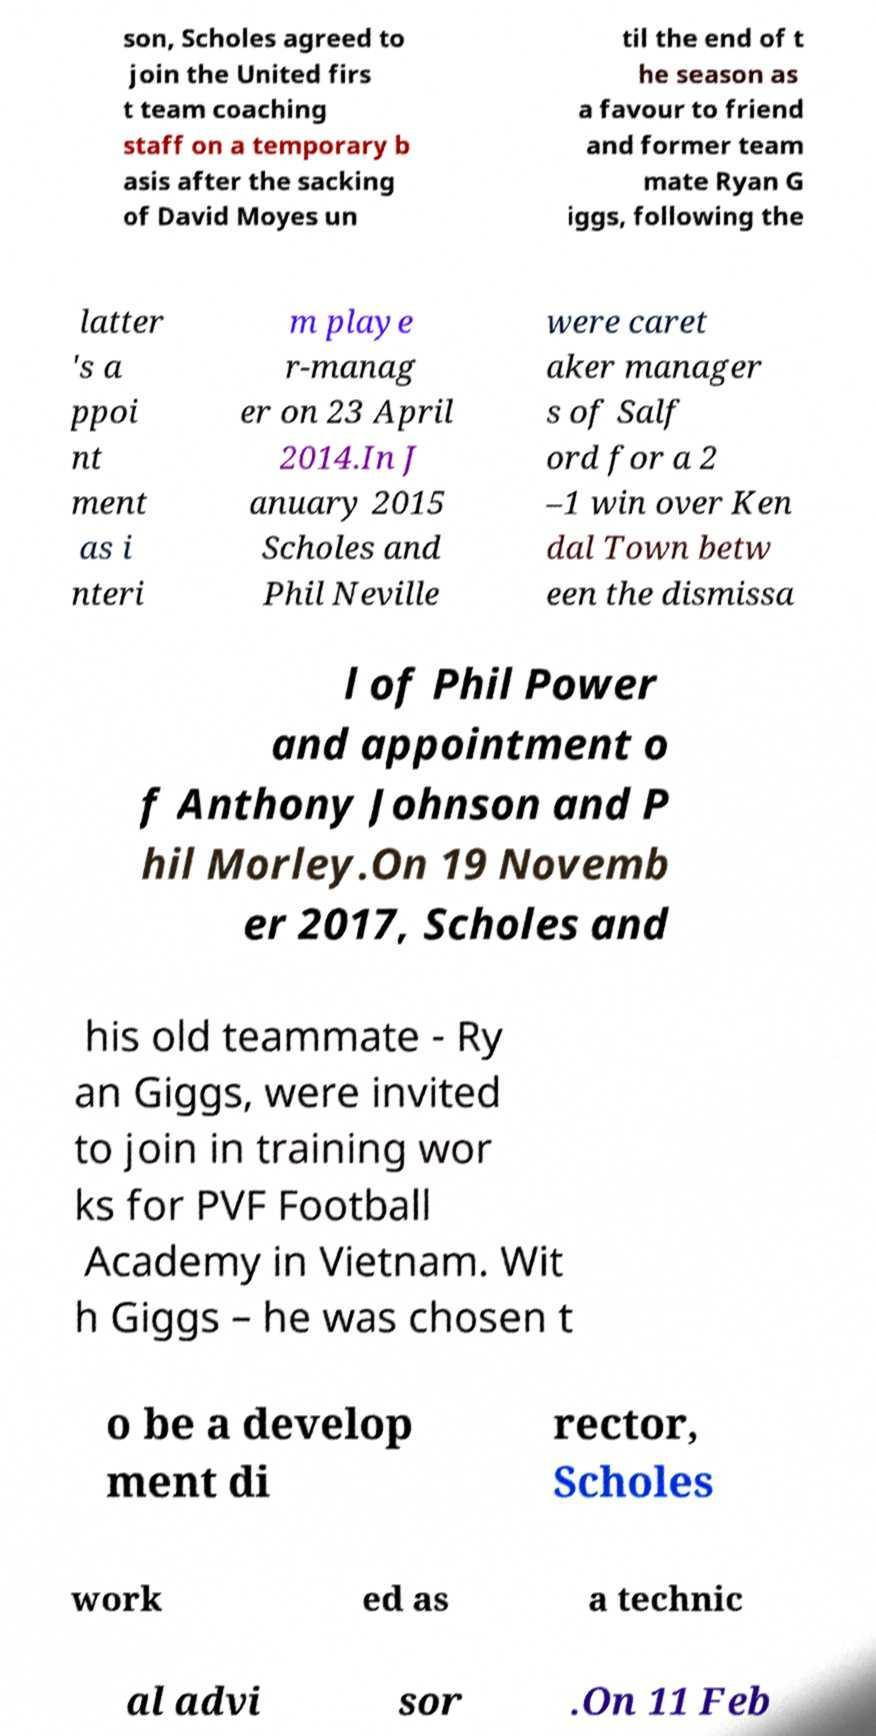Please read and relay the text visible in this image. What does it say? son, Scholes agreed to join the United firs t team coaching staff on a temporary b asis after the sacking of David Moyes un til the end of t he season as a favour to friend and former team mate Ryan G iggs, following the latter 's a ppoi nt ment as i nteri m playe r-manag er on 23 April 2014.In J anuary 2015 Scholes and Phil Neville were caret aker manager s of Salf ord for a 2 –1 win over Ken dal Town betw een the dismissa l of Phil Power and appointment o f Anthony Johnson and P hil Morley.On 19 Novemb er 2017, Scholes and his old teammate - Ry an Giggs, were invited to join in training wor ks for PVF Football Academy in Vietnam. Wit h Giggs – he was chosen t o be a develop ment di rector, Scholes work ed as a technic al advi sor .On 11 Feb 